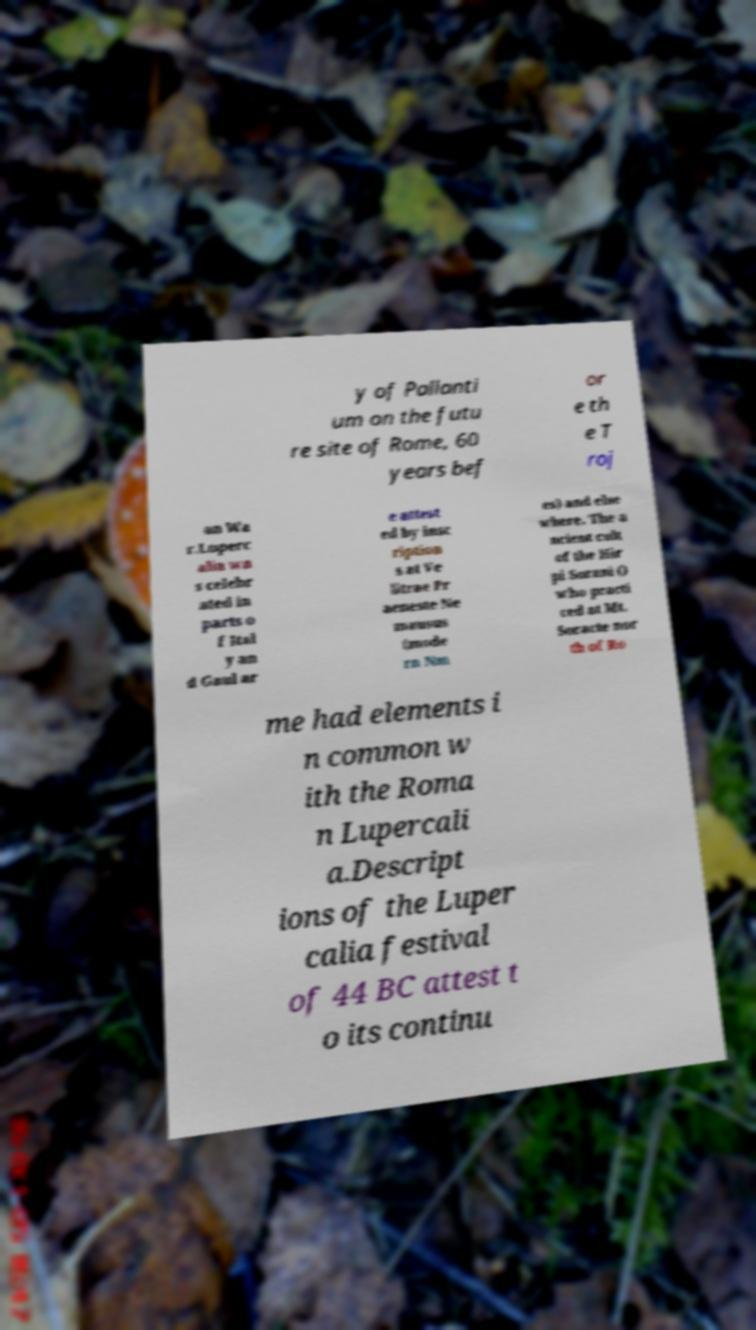Please read and relay the text visible in this image. What does it say? y of Pallanti um on the futu re site of Rome, 60 years bef or e th e T roj an Wa r.Luperc alia wa s celebr ated in parts o f Ital y an d Gaul ar e attest ed by insc ription s at Ve litrae Pr aeneste Ne mausus (mode rn Nm es) and else where. The a ncient cult of the Hir pi Sorani () who practi ced at Mt. Soracte nor th of Ro me had elements i n common w ith the Roma n Lupercali a.Descript ions of the Luper calia festival of 44 BC attest t o its continu 